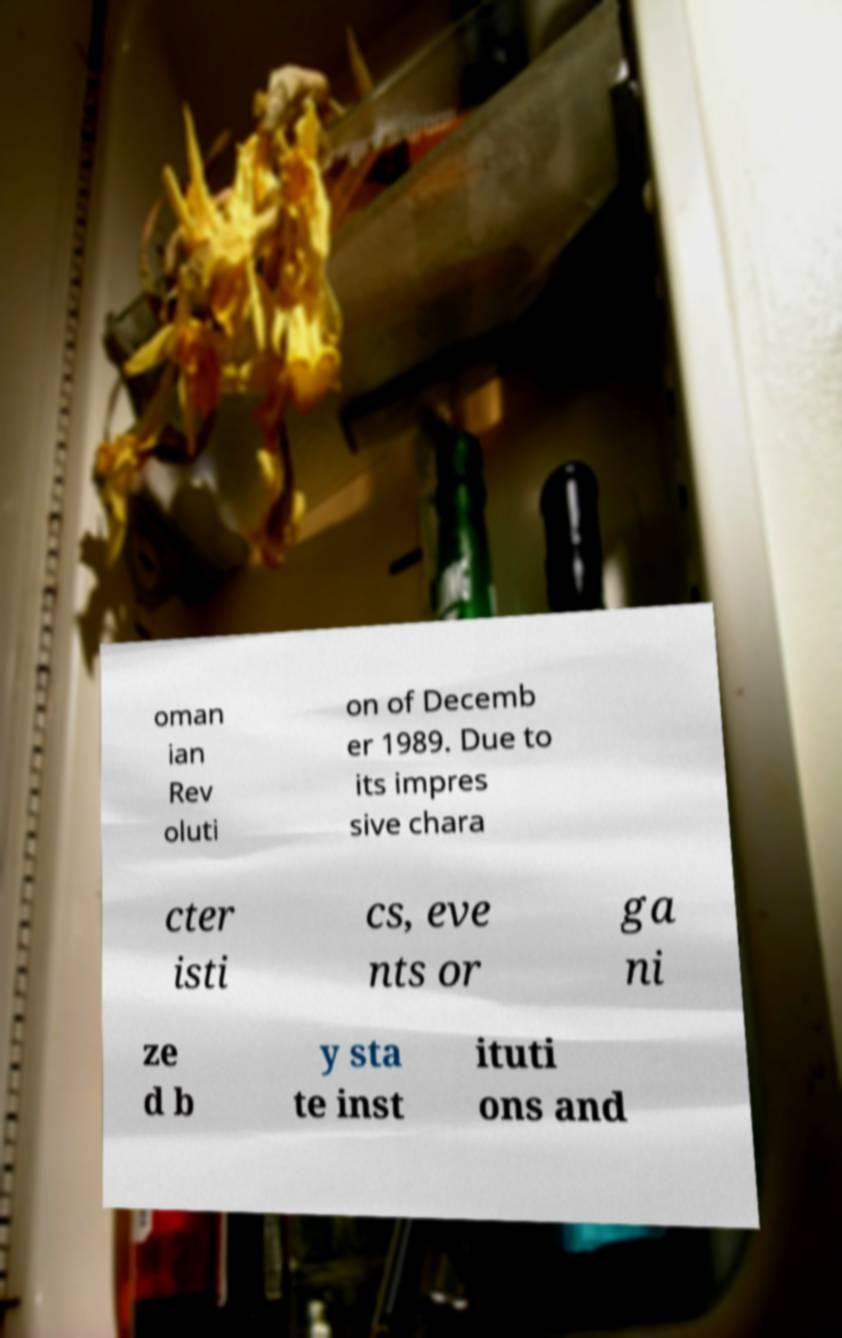What messages or text are displayed in this image? I need them in a readable, typed format. oman ian Rev oluti on of Decemb er 1989. Due to its impres sive chara cter isti cs, eve nts or ga ni ze d b y sta te inst ituti ons and 